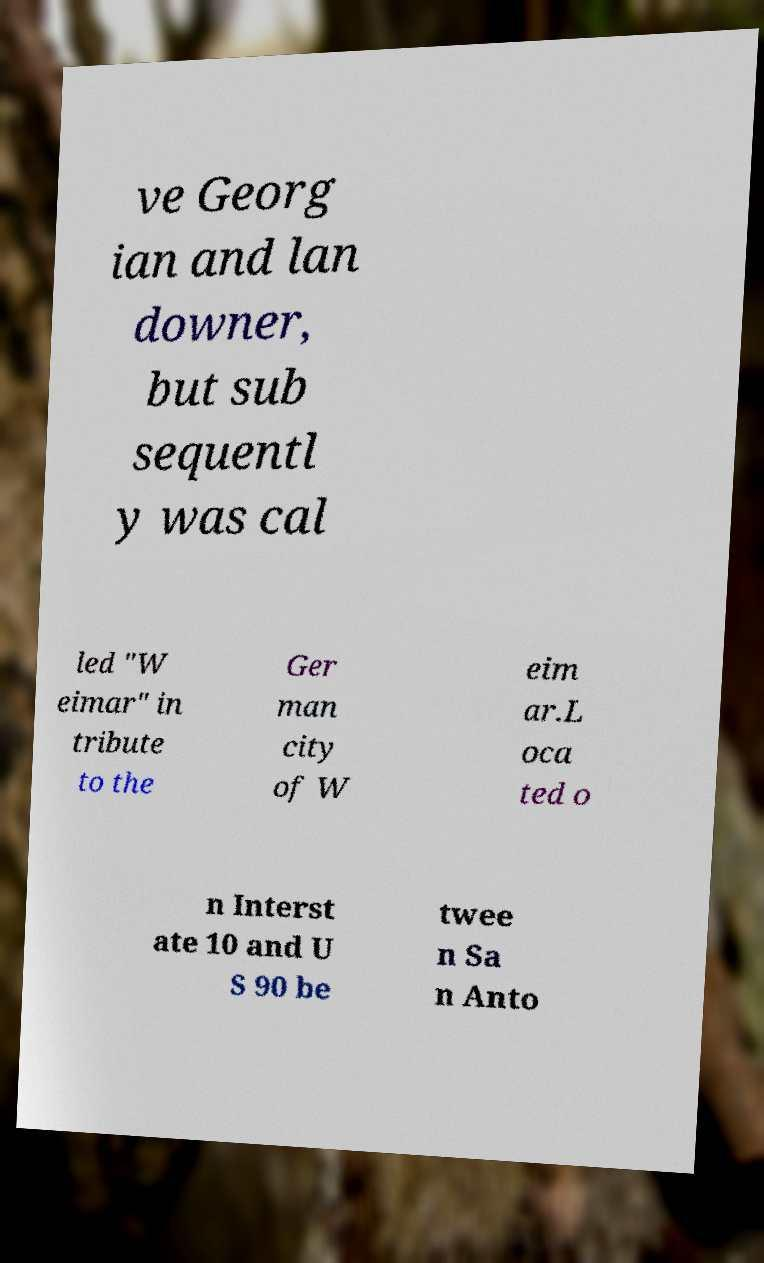Please identify and transcribe the text found in this image. ve Georg ian and lan downer, but sub sequentl y was cal led "W eimar" in tribute to the Ger man city of W eim ar.L oca ted o n Interst ate 10 and U S 90 be twee n Sa n Anto 